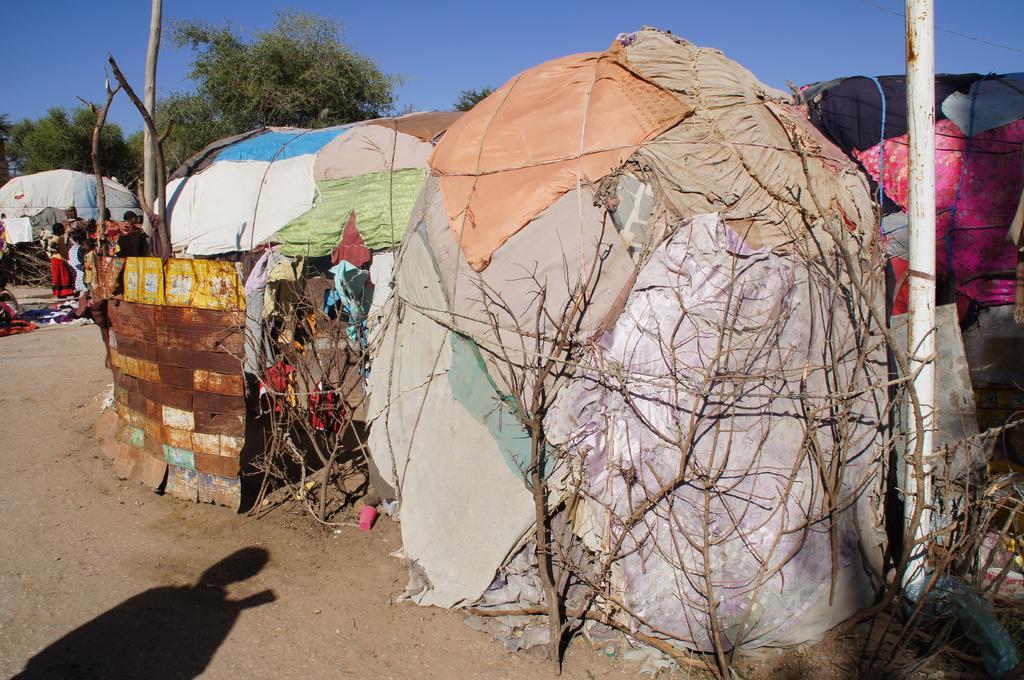In one or two sentences, can you explain what this image depicts? This is the picture of a place where we have some tents of cloth, stems and also we can see some people, trees and pole to the side. 